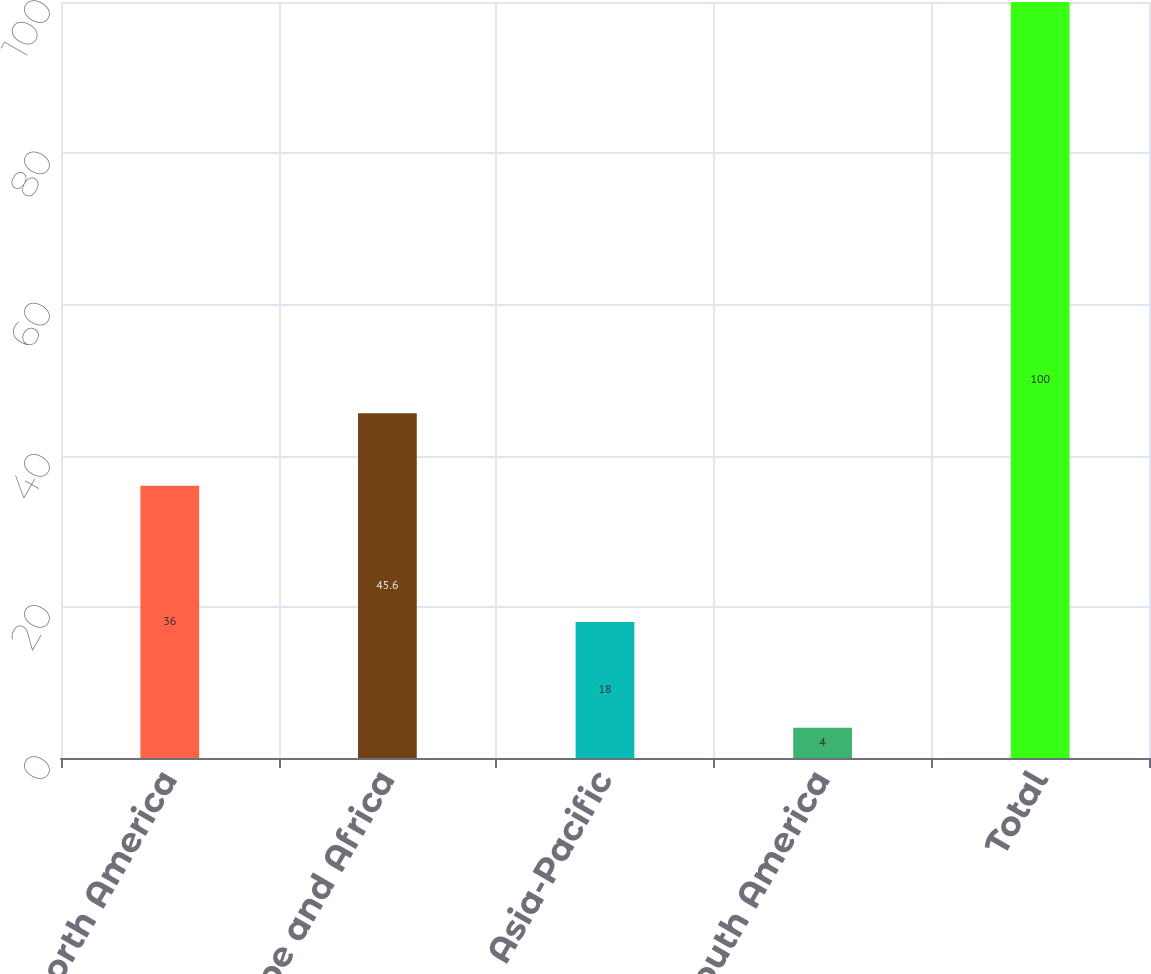<chart> <loc_0><loc_0><loc_500><loc_500><bar_chart><fcel>North America<fcel>Europe and Africa<fcel>Asia-Pacific<fcel>South America<fcel>Total<nl><fcel>36<fcel>45.6<fcel>18<fcel>4<fcel>100<nl></chart> 